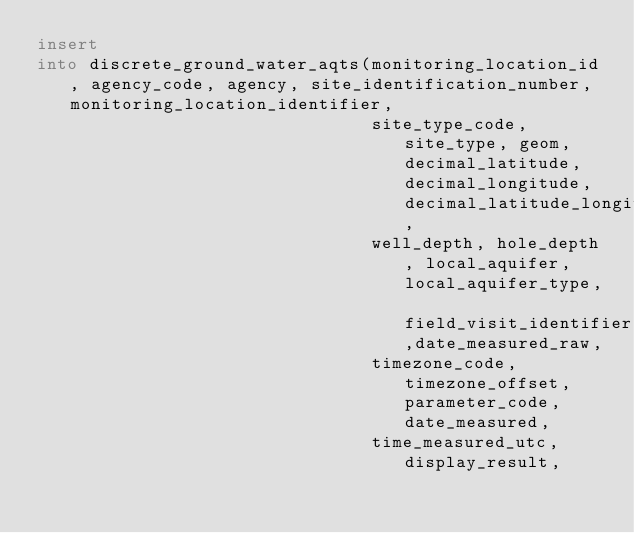Convert code to text. <code><loc_0><loc_0><loc_500><loc_500><_SQL_>insert
into discrete_ground_water_aqts(monitoring_location_id, agency_code, agency, site_identification_number, monitoring_location_identifier,
                                site_type_code, site_type, geom, decimal_latitude, decimal_longitude, decimal_latitude_longitude_datum,
                                well_depth, hole_depth, local_aquifer, local_aquifer_type, field_visit_identifier,date_measured_raw,
                                timezone_code, timezone_offset, parameter_code, date_measured,
                                time_measured_utc, display_result,</code> 